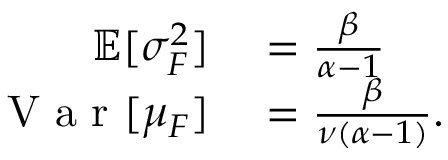<formula> <loc_0><loc_0><loc_500><loc_500>\begin{array} { r l } { \mathbb { E } [ \sigma _ { F } ^ { 2 } ] } & = \frac { \beta } { \alpha - 1 } } \\ { V a r [ \mu _ { F } ] } & = \frac { \beta } { \nu ( \alpha - 1 ) } . } \end{array}</formula> 